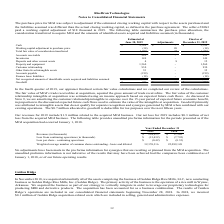From Ricebran Technologies's financial document, What are the respective revenues in 2018 and 2019? The document shows two values: $ 17,542 and $ 224,913 (in thousands). From the document: "Revenues (in thousands) 224,913 $ 17,542 $ Revenues (in thousands) 224,913 $ 17,542 $..." Also, What are the respective loss from continuing operations in 2018 and 2019? The document shows two values: 7,792 and 13,432 (in thousands). From the document: "continuing operations (in thousands) (13,432) $ (7,792) $ Loss from continuing operations (in thousands) (13,432) $ (7,792) $..." Also, What are the revenue and net loss for 2019? The document shows two values: $1.9 million and $0.3 million. From the document: "next fifteen years. Our revenues for 2019 include $1.9 million related to the acquired MGI business. Our net loss for 2019 includes $0.3 million of ne..." Also, can you calculate: What is the change in loss per share between 2018 and 2019? Based on the calculation: -0.42 + 0.35 , the result is -0.07. This is based on the information: "Loss per share - continuing operations (0.42) $ (0.35) $ Loss per share - continuing operations (0.42) $ (0.35) $..." The key data points involved are: 0.35, 0.42. Also, can you calculate: What is the average loss per share between 2018 and 2019? To answer this question, I need to perform calculations using the financial data. The calculation is: (0.42 + 0.35)/2 , which equals 0.39. This is based on the information: "Loss per share - continuing operations (0.42) $ (0.35) $ Loss per share - continuing operations (0.42) $ (0.35) $..." The key data points involved are: 0.35, 0.42. Additionally, Which year has the highest Weighted average number of common shares outstanding - basic and diluted? According to the financial document, 2019. The relevant text states: "2019 2018..." 